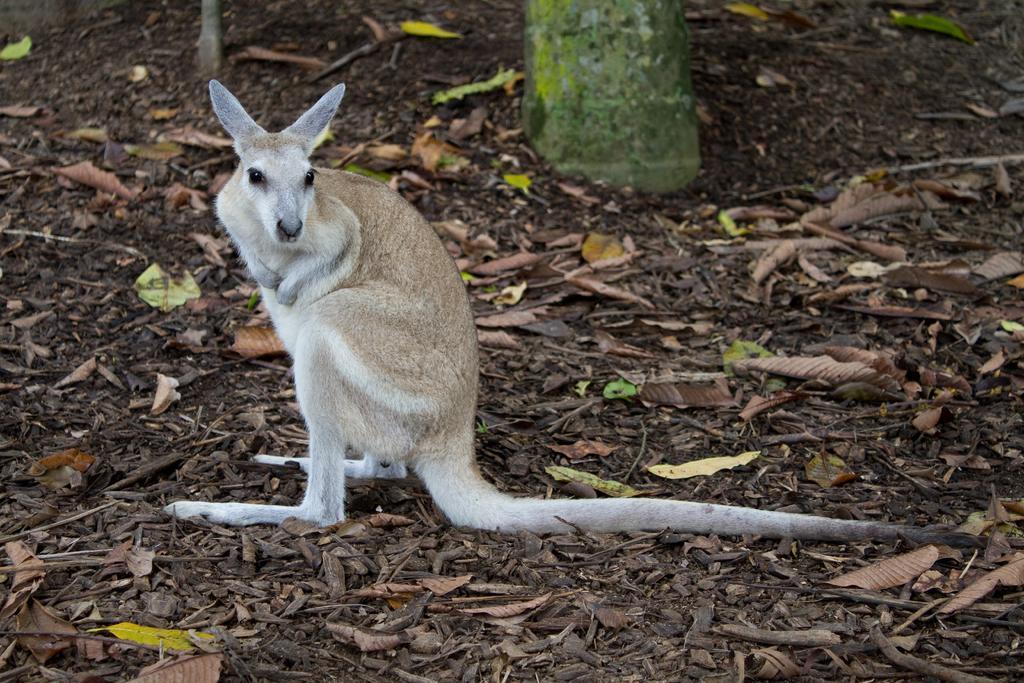How would you summarize this image in a sentence or two? In this image, I can see a kangaroo. There are dried leaves on the ground. At the top of the image, It looks like a tree trunk. 